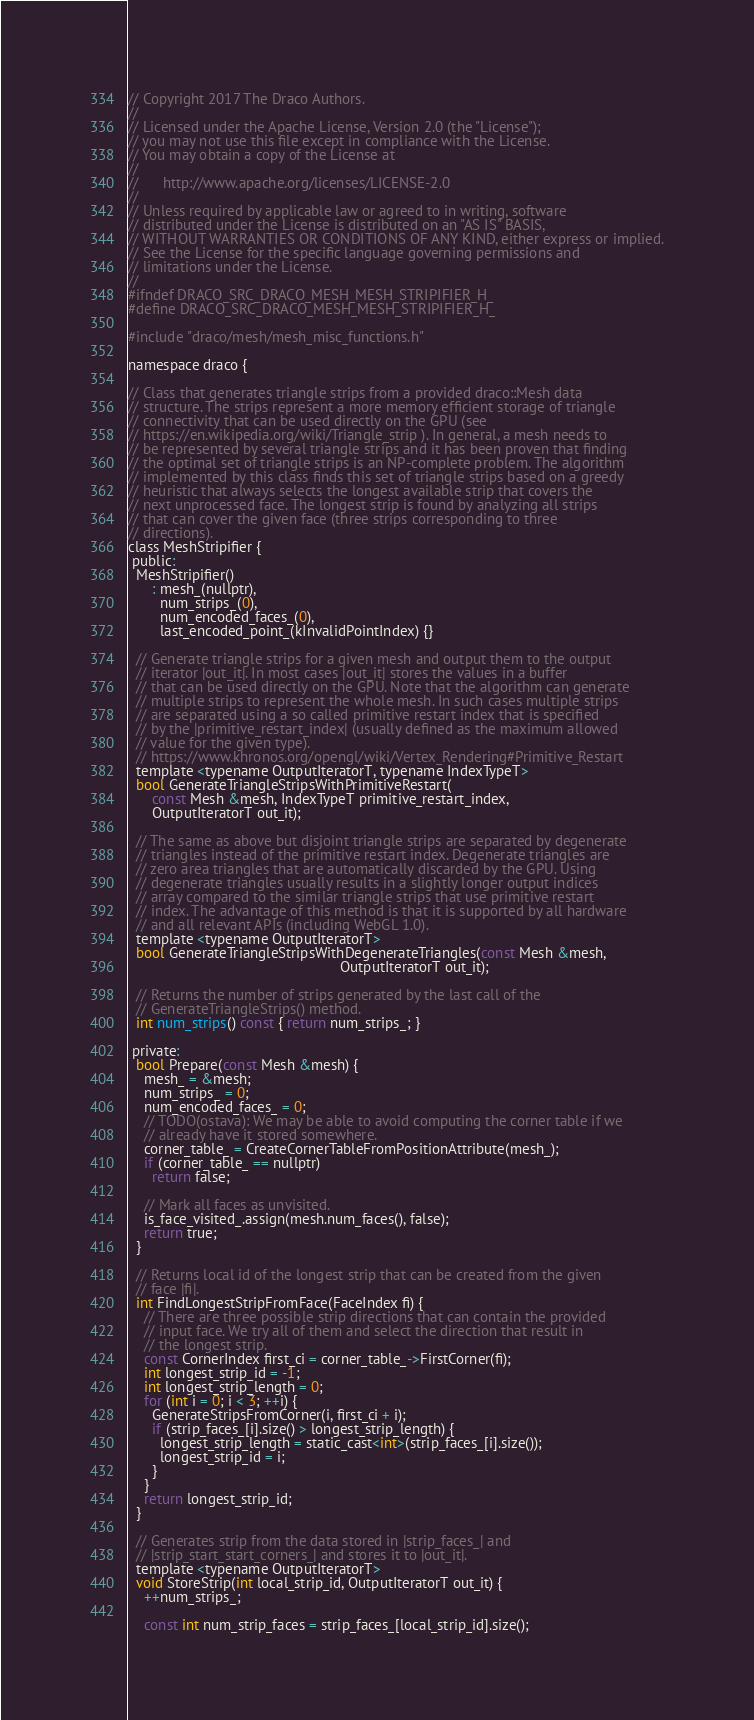Convert code to text. <code><loc_0><loc_0><loc_500><loc_500><_C_>// Copyright 2017 The Draco Authors.
//
// Licensed under the Apache License, Version 2.0 (the "License");
// you may not use this file except in compliance with the License.
// You may obtain a copy of the License at
//
//      http://www.apache.org/licenses/LICENSE-2.0
//
// Unless required by applicable law or agreed to in writing, software
// distributed under the License is distributed on an "AS IS" BASIS,
// WITHOUT WARRANTIES OR CONDITIONS OF ANY KIND, either express or implied.
// See the License for the specific language governing permissions and
// limitations under the License.
//
#ifndef DRACO_SRC_DRACO_MESH_MESH_STRIPIFIER_H_
#define DRACO_SRC_DRACO_MESH_MESH_STRIPIFIER_H_

#include "draco/mesh/mesh_misc_functions.h"

namespace draco {

// Class that generates triangle strips from a provided draco::Mesh data
// structure. The strips represent a more memory efficient storage of triangle
// connectivity that can be used directly on the GPU (see
// https://en.wikipedia.org/wiki/Triangle_strip ). In general, a mesh needs to
// be represented by several triangle strips and it has been proven that finding
// the optimal set of triangle strips is an NP-complete problem. The algorithm
// implemented by this class finds this set of triangle strips based on a greedy
// heuristic that always selects the longest available strip that covers the
// next unprocessed face. The longest strip is found by analyzing all strips
// that can cover the given face (three strips corresponding to three
// directions).
class MeshStripifier {
 public:
  MeshStripifier()
      : mesh_(nullptr),
        num_strips_(0),
        num_encoded_faces_(0),
        last_encoded_point_(kInvalidPointIndex) {}

  // Generate triangle strips for a given mesh and output them to the output
  // iterator |out_it|. In most cases |out_it| stores the values in a buffer
  // that can be used directly on the GPU. Note that the algorithm can generate
  // multiple strips to represent the whole mesh. In such cases multiple strips
  // are separated using a so called primitive restart index that is specified
  // by the |primitive_restart_index| (usually defined as the maximum allowed
  // value for the given type).
  // https://www.khronos.org/opengl/wiki/Vertex_Rendering#Primitive_Restart
  template <typename OutputIteratorT, typename IndexTypeT>
  bool GenerateTriangleStripsWithPrimitiveRestart(
      const Mesh &mesh, IndexTypeT primitive_restart_index,
      OutputIteratorT out_it);

  // The same as above but disjoint triangle strips are separated by degenerate
  // triangles instead of the primitive restart index. Degenerate triangles are
  // zero area triangles that are automatically discarded by the GPU. Using
  // degenerate triangles usually results in a slightly longer output indices
  // array compared to the similar triangle strips that use primitive restart
  // index. The advantage of this method is that it is supported by all hardware
  // and all relevant APIs (including WebGL 1.0).
  template <typename OutputIteratorT>
  bool GenerateTriangleStripsWithDegenerateTriangles(const Mesh &mesh,
                                                     OutputIteratorT out_it);

  // Returns the number of strips generated by the last call of the
  // GenerateTriangleStrips() method.
  int num_strips() const { return num_strips_; }

 private:
  bool Prepare(const Mesh &mesh) {
    mesh_ = &mesh;
    num_strips_ = 0;
    num_encoded_faces_ = 0;
    // TODO(ostava): We may be able to avoid computing the corner table if we
    // already have it stored somewhere.
    corner_table_ = CreateCornerTableFromPositionAttribute(mesh_);
    if (corner_table_ == nullptr)
      return false;

    // Mark all faces as unvisited.
    is_face_visited_.assign(mesh.num_faces(), false);
    return true;
  }

  // Returns local id of the longest strip that can be created from the given
  // face |fi|.
  int FindLongestStripFromFace(FaceIndex fi) {
    // There are three possible strip directions that can contain the provided
    // input face. We try all of them and select the direction that result in
    // the longest strip.
    const CornerIndex first_ci = corner_table_->FirstCorner(fi);
    int longest_strip_id = -1;
    int longest_strip_length = 0;
    for (int i = 0; i < 3; ++i) {
      GenerateStripsFromCorner(i, first_ci + i);
      if (strip_faces_[i].size() > longest_strip_length) {
        longest_strip_length = static_cast<int>(strip_faces_[i].size());
        longest_strip_id = i;
      }
    }
    return longest_strip_id;
  }

  // Generates strip from the data stored in |strip_faces_| and
  // |strip_start_start_corners_| and stores it to |out_it|.
  template <typename OutputIteratorT>
  void StoreStrip(int local_strip_id, OutputIteratorT out_it) {
    ++num_strips_;

    const int num_strip_faces = strip_faces_[local_strip_id].size();</code> 